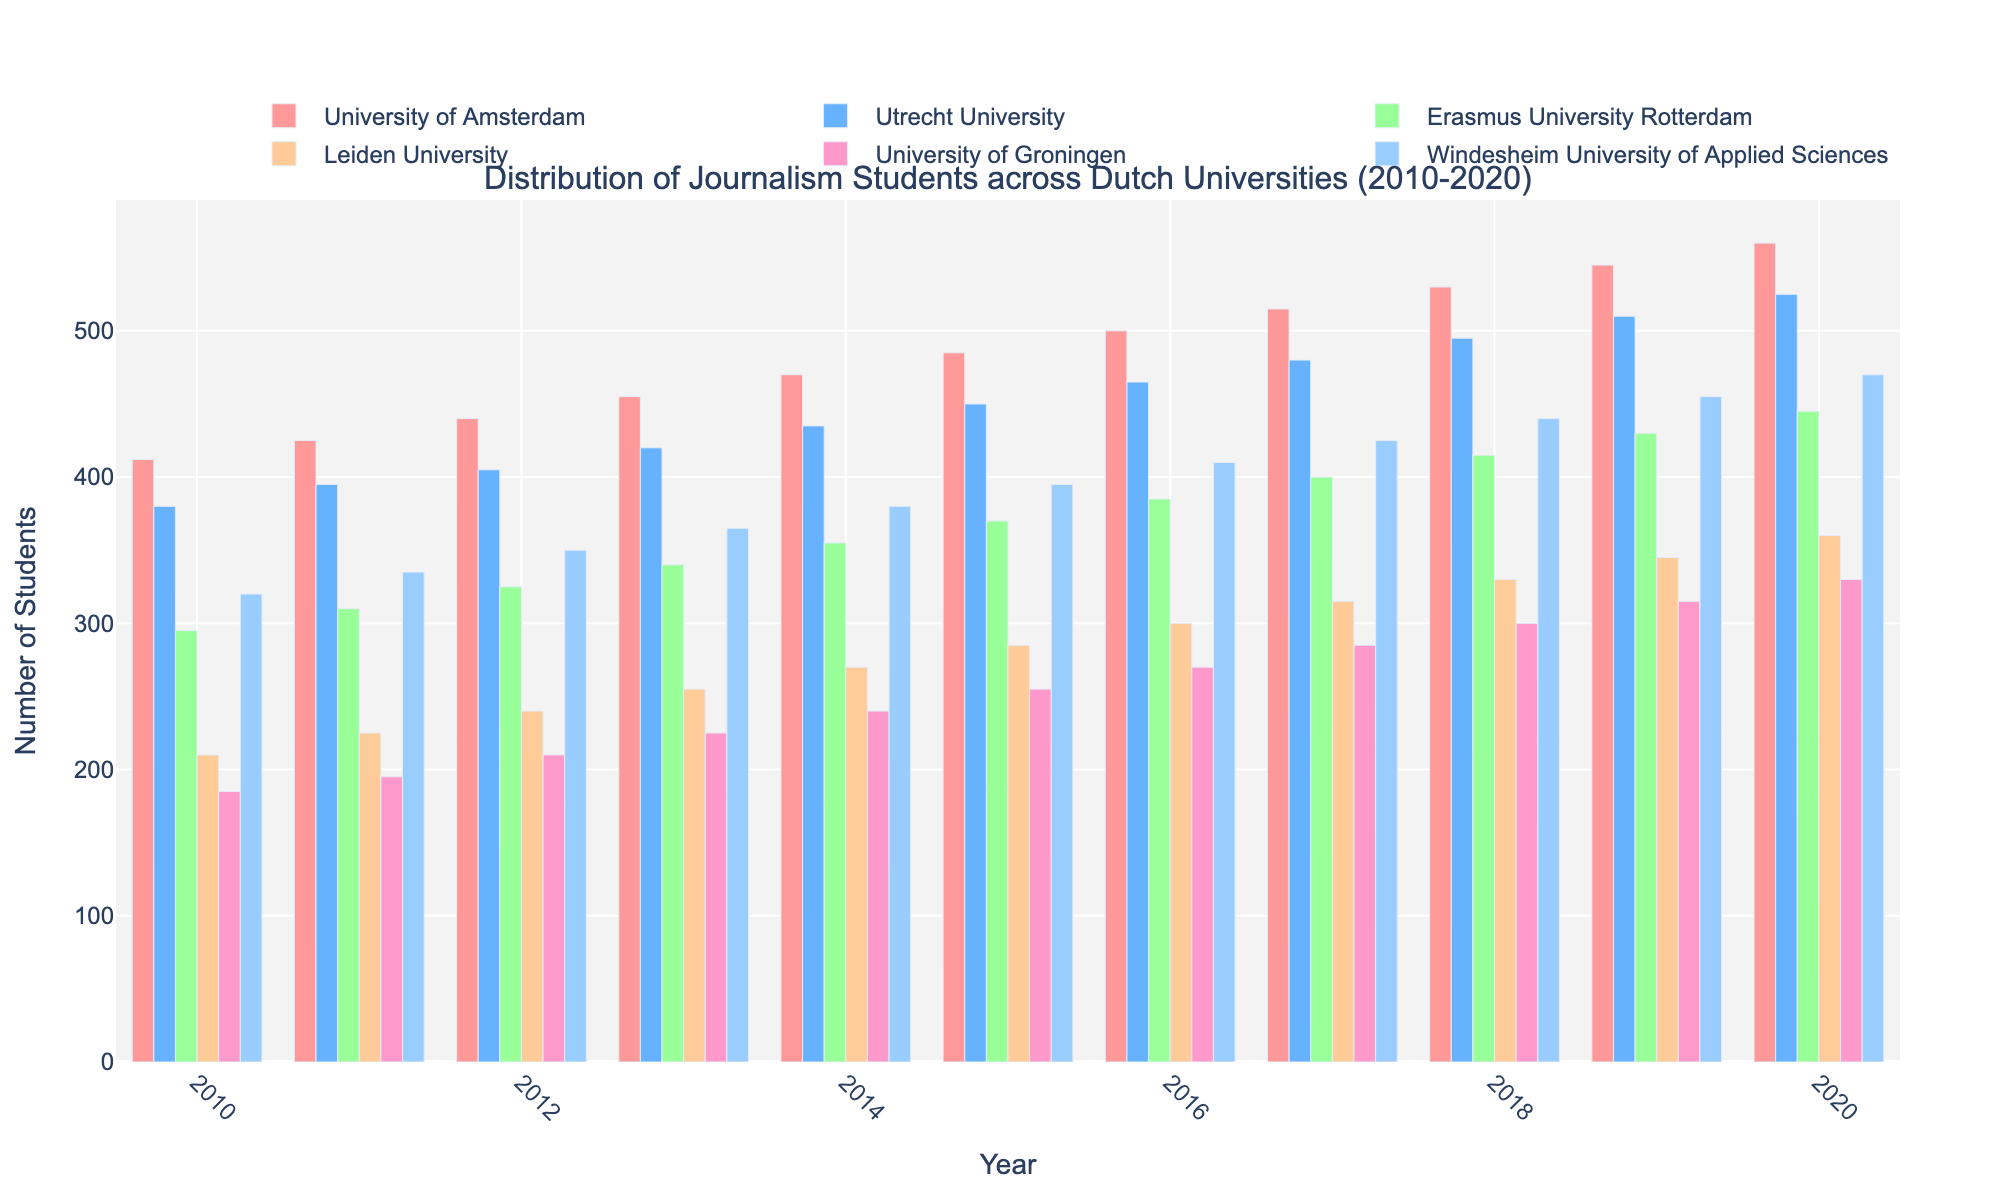What's the trend of student enrollment at the University of Amsterdam from 2010 to 2020? The trend can be observed by looking at the height of the bars representing student enrollments at the University of Amsterdam over the years. Each bar increases in height each year, showing a steady increase.
Answer: Increasing Which university had the highest number of journalism students in 2020? To determine which university had the highest enrollment in 2020, compare the heights of the 2020 bars for all universities. The University of Amsterdam's bar is the tallest.
Answer: University of Amsterdam What is the total number of journalism students at Utrecht University and Erasmus University Rotterdam in 2015? First, identify the 2015 bars for both universities. Utrecht University had 450 students, and Erasmus University Rotterdam had 370 students. Adding these gives 450 + 370.
Answer: 820 How does the growth in students at Windesheim University of Applied Sciences compare to Leiden University from 2010 to 2020? Observe the change in bar heights from 2010 to 2020 for both universities. Windesheim University of Applied Sciences grew from 320 to 470 students, an increase of 150. Leiden University grew from 210 to 360 students, an increase of 150 as well.
Answer: Equal What was the smallest enrollment growth among the universities from 2010 to 2020? Calculate the growth by subtracting the 2010 value from the 2020 value for each university. University of Groningen had the smallest growth, increasing from 185 to 330, which is 145 students.
Answer: University of Groningen Which year had the highest total number of students across all universities? Add the number of students for all universities for each year and compare. Calculations for each year will show that 2020 had the highest total.
Answer: 2020 How many students were enrolled in journalism at the University of Groningen in 2013 compared to Windesheim in 2013? Identify the bars for 2013 for both universities. University of Groningen had 225 students, and Windesheim had 365 students.
Answer: University of Groningen: 225, Windesheim: 365 If you add the number of students in 2010 and 2015 for Leiden University, what is the result? Identify the bars for those years for Leiden University. In 2010, there were 210 students, and in 2015, there were 285 students. Adding these gives 210 + 285.
Answer: 495 Which two universities had the largest difference in student enrollment in 2020? Compare the 2020 bars. University of Amsterdam had 560 students and University of Groningen had 330 students. The difference is 560 - 330.
Answer: University of Amsterdam and University of Groningen 